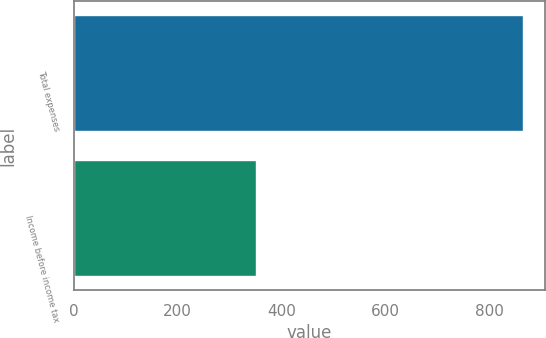Convert chart. <chart><loc_0><loc_0><loc_500><loc_500><bar_chart><fcel>Total expenses<fcel>Income before income tax<nl><fcel>864<fcel>350<nl></chart> 